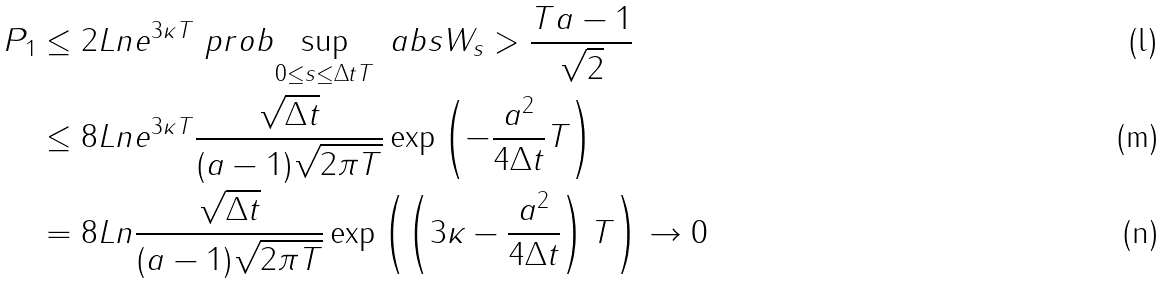<formula> <loc_0><loc_0><loc_500><loc_500>P _ { 1 } & \leq 2 L n e ^ { 3 \kappa T } \ p r o b { \sup _ { 0 \leq s \leq \Delta t T } \ a b s { W _ { s } } > \frac { T a - 1 } { \sqrt { 2 } } } \\ & \leq 8 L n e ^ { 3 \kappa T } \frac { \sqrt { \Delta t } } { ( a - 1 ) \sqrt { 2 \pi T } } \exp \left ( - \frac { a ^ { 2 } } { 4 \Delta t } T \right ) \\ & = 8 L n \frac { \sqrt { \Delta t } } { ( a - 1 ) \sqrt { 2 \pi T } } \exp \left ( \left ( 3 \kappa - \frac { a ^ { 2 } } { 4 \Delta t } \right ) T \right ) \to 0</formula> 